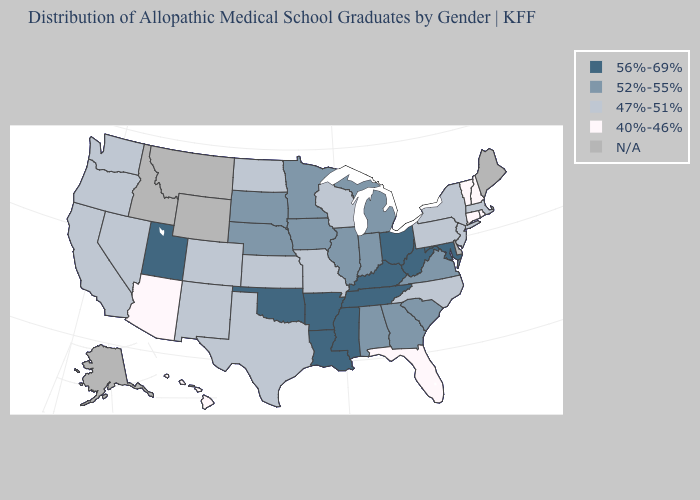What is the lowest value in the South?
Keep it brief. 40%-46%. Name the states that have a value in the range 40%-46%?
Keep it brief. Arizona, Connecticut, Florida, Hawaii, New Hampshire, Rhode Island, Vermont. What is the value of New York?
Give a very brief answer. 47%-51%. Does North Dakota have the lowest value in the MidWest?
Keep it brief. Yes. Name the states that have a value in the range N/A?
Concise answer only. Alaska, Delaware, Idaho, Maine, Montana, Wyoming. What is the value of Iowa?
Quick response, please. 52%-55%. Name the states that have a value in the range 47%-51%?
Write a very short answer. California, Colorado, Kansas, Massachusetts, Missouri, Nevada, New Jersey, New Mexico, New York, North Carolina, North Dakota, Oregon, Pennsylvania, Texas, Washington, Wisconsin. What is the highest value in the MidWest ?
Give a very brief answer. 56%-69%. Among the states that border Montana , which have the highest value?
Quick response, please. South Dakota. 